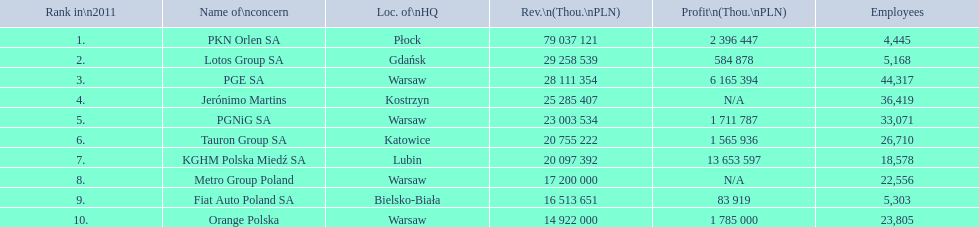What is the number of employees that work for pkn orlen sa in poland? 4,445. What number of employees work for lotos group sa? 5,168. How many people work for pgnig sa? 33,071. 